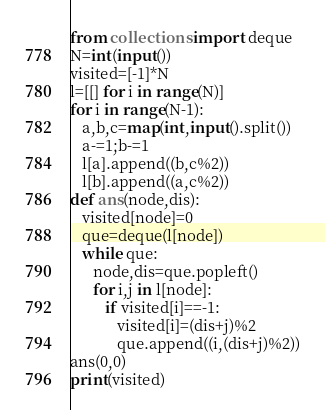Convert code to text. <code><loc_0><loc_0><loc_500><loc_500><_Python_>from collections import deque
N=int(input())
visited=[-1]*N
l=[[] for i in range(N)]
for i in range(N-1):
   a,b,c=map(int,input().split())
   a-=1;b-=1
   l[a].append((b,c%2))
   l[b].append((a,c%2))
def ans(node,dis):
   visited[node]=0
   que=deque(l[node])
   while que:
      node,dis=que.popleft()
      for i,j in l[node]:
         if visited[i]==-1:
            visited[i]=(dis+j)%2
            que.append((i,(dis+j)%2))
ans(0,0)
print(visited)</code> 